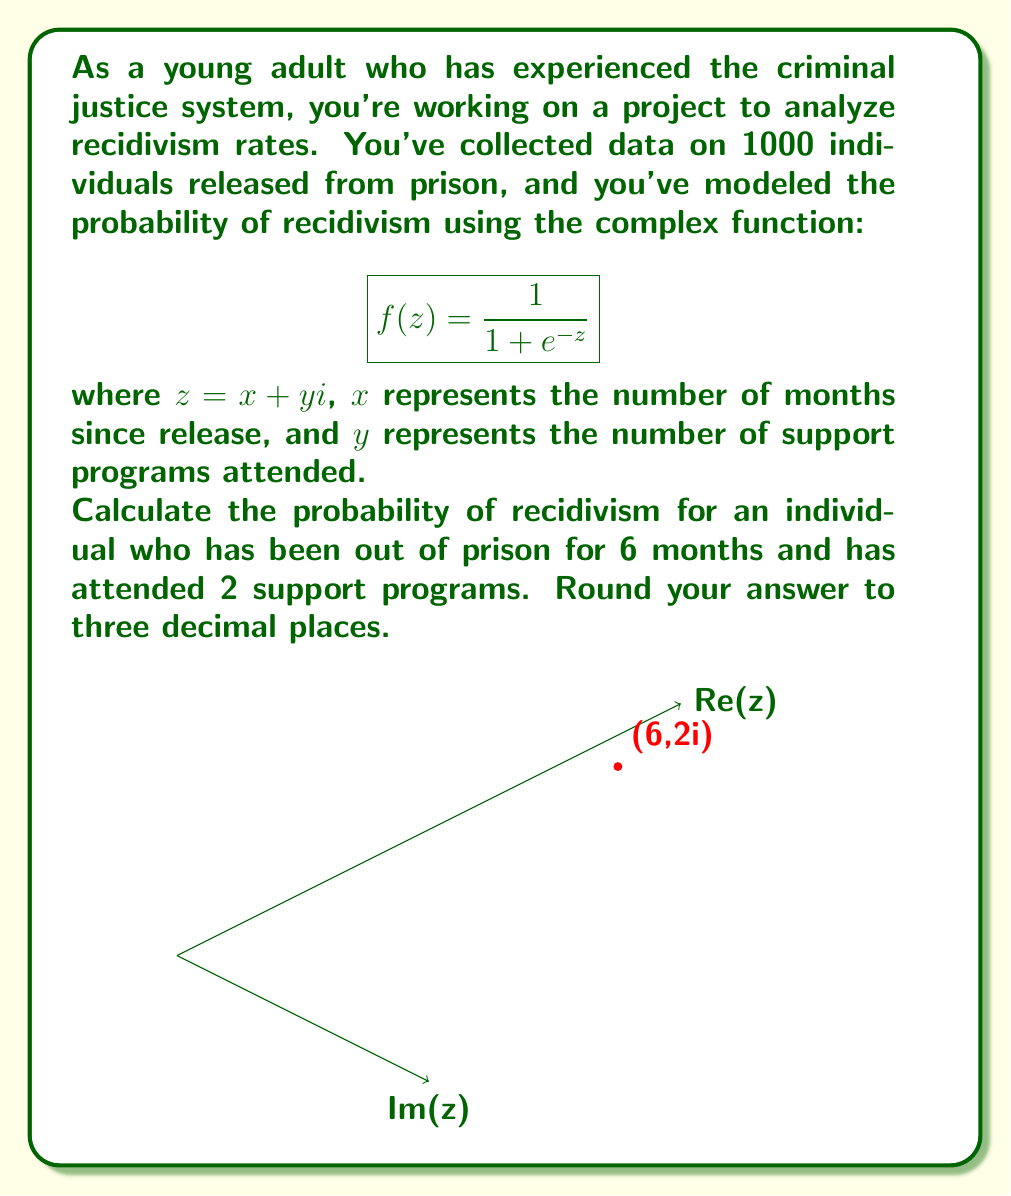Help me with this question. Let's approach this step-by-step:

1) We're given the complex function for the probability of recidivism:
   $$f(z) = \frac{1}{1 + e^{-z}}$$

2) In our case, $z = x + yi$ where:
   $x = 6$ (6 months since release)
   $y = 2$ (2 support programs attended)

3) So, we need to calculate:
   $$f(6 + 2i) = \frac{1}{1 + e^{-(6 + 2i)}}$$

4) Let's simplify the exponent first:
   $$e^{-(6 + 2i)} = e^{-6} \cdot e^{-2i}$$

5) Using Euler's formula, $e^{-2i} = \cos(-2) - i\sin(-2) = \cos(2) + i\sin(2)$

6) Now our function looks like:
   $$f(6 + 2i) = \frac{1}{1 + e^{-6}(\cos(2) + i\sin(2))}$$

7) Let $a = e^{-6}\cos(2)$ and $b = e^{-6}\sin(2)$. Then we have:
   $$f(6 + 2i) = \frac{1}{1 + a + bi}$$

8) To find the magnitude of this complex number (which represents the probability), we use:
   $$|f(6 + 2i)| = \sqrt{\frac{1}{(1+a)^2 + b^2}}$$

9) Calculating the values:
   $e^{-6} \approx 0.00247875$
   $a = e^{-6}\cos(2) \approx -0.00223103$
   $b = e^{-6}\sin(2) \approx 0.00108047$

10) Plugging these into our equation:
    $$|f(6 + 2i)| = \sqrt{\frac{1}{(1-0.00223103)^2 + 0.00108047^2}} \approx 0.998$$

Therefore, the probability of recidivism is approximately 0.998 or 99.8%.
Answer: 0.998 